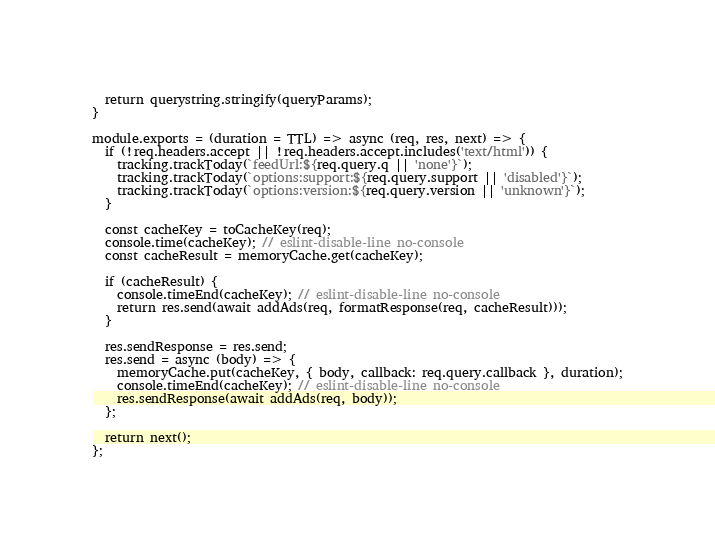<code> <loc_0><loc_0><loc_500><loc_500><_JavaScript_>  return querystring.stringify(queryParams);
}

module.exports = (duration = TTL) => async (req, res, next) => {
  if (!req.headers.accept || !req.headers.accept.includes('text/html')) {
    tracking.trackToday(`feedUrl:${req.query.q || 'none'}`);
    tracking.trackToday(`options:support:${req.query.support || 'disabled'}`);
    tracking.trackToday(`options:version:${req.query.version || 'unknown'}`);
  }

  const cacheKey = toCacheKey(req);
  console.time(cacheKey); // eslint-disable-line no-console
  const cacheResult = memoryCache.get(cacheKey);

  if (cacheResult) {
    console.timeEnd(cacheKey); // eslint-disable-line no-console
    return res.send(await addAds(req, formatResponse(req, cacheResult)));
  }

  res.sendResponse = res.send;
  res.send = async (body) => {
    memoryCache.put(cacheKey, { body, callback: req.query.callback }, duration);
    console.timeEnd(cacheKey); // eslint-disable-line no-console
    res.sendResponse(await addAds(req, body));
  };

  return next();
};
</code> 